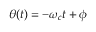Convert formula to latex. <formula><loc_0><loc_0><loc_500><loc_500>\theta ( t ) = - \omega _ { c } t + \phi</formula> 